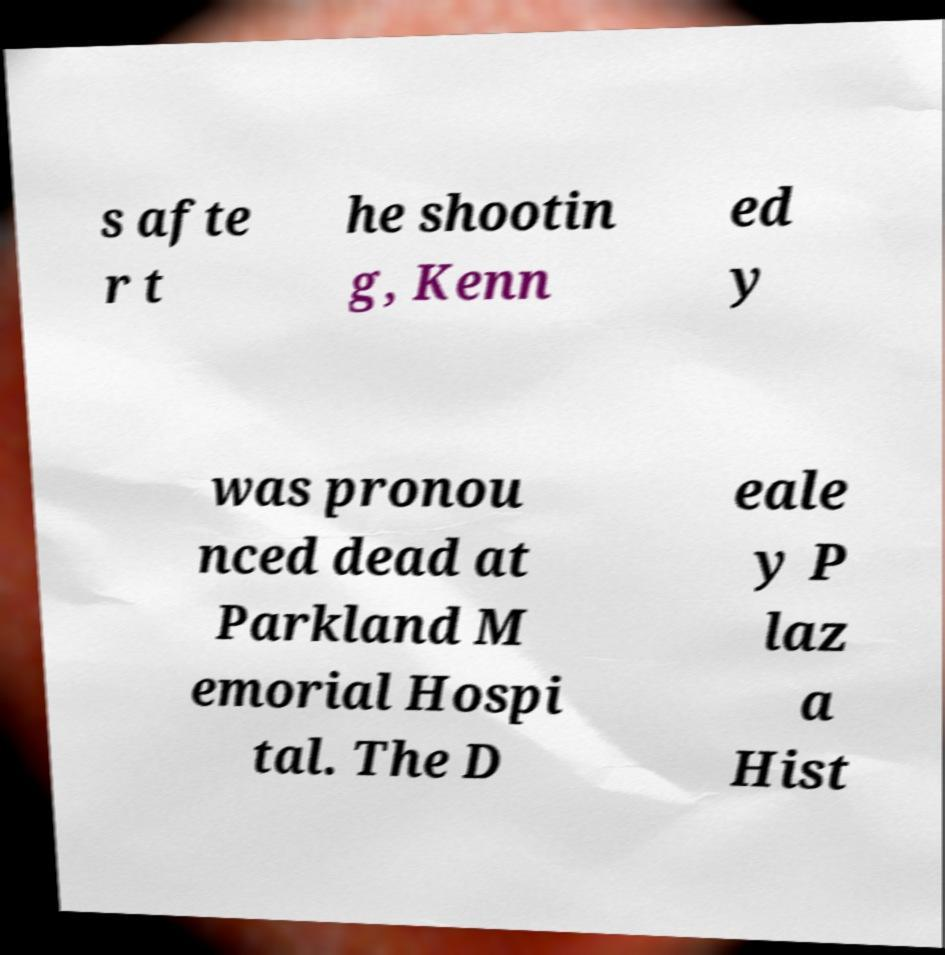What messages or text are displayed in this image? I need them in a readable, typed format. s afte r t he shootin g, Kenn ed y was pronou nced dead at Parkland M emorial Hospi tal. The D eale y P laz a Hist 